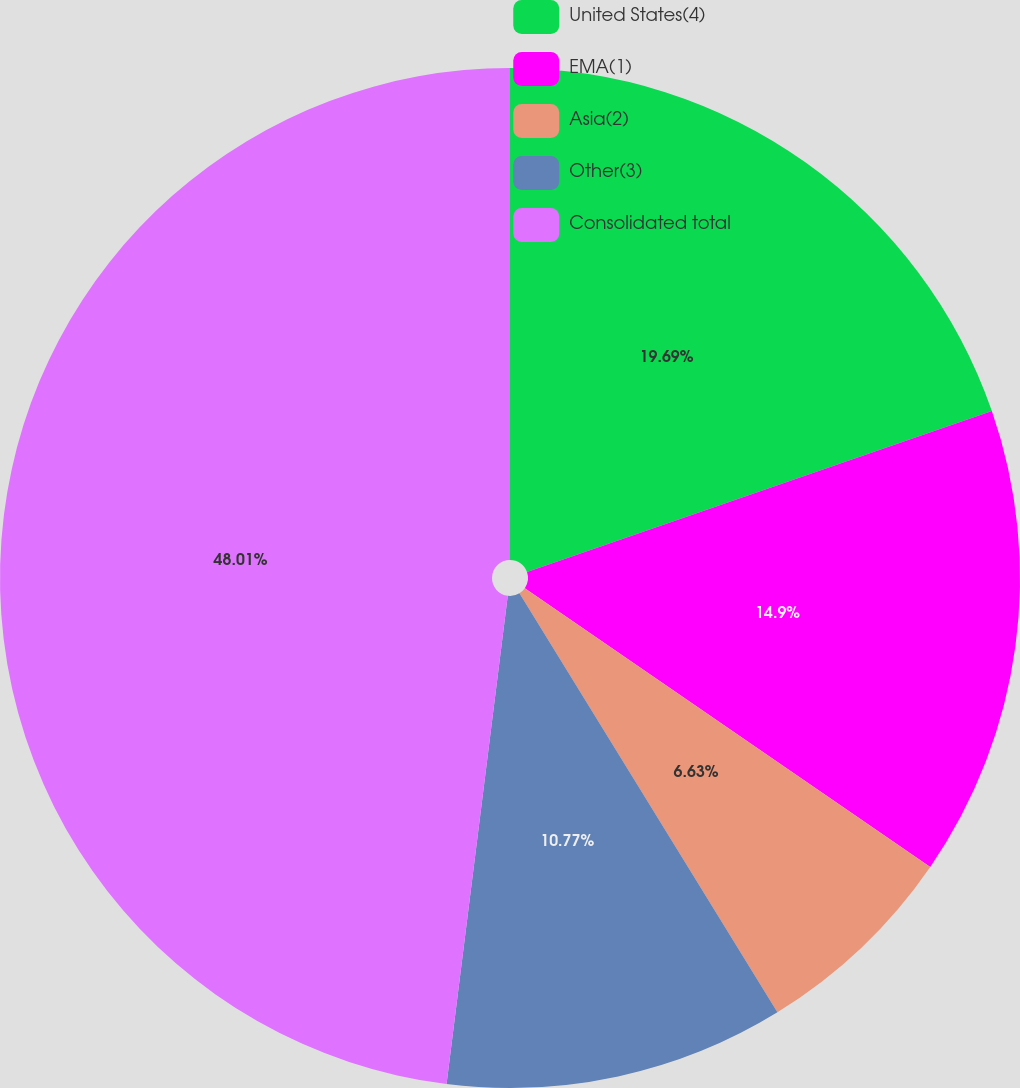<chart> <loc_0><loc_0><loc_500><loc_500><pie_chart><fcel>United States(4)<fcel>EMA(1)<fcel>Asia(2)<fcel>Other(3)<fcel>Consolidated total<nl><fcel>19.69%<fcel>14.9%<fcel>6.63%<fcel>10.77%<fcel>48.02%<nl></chart> 